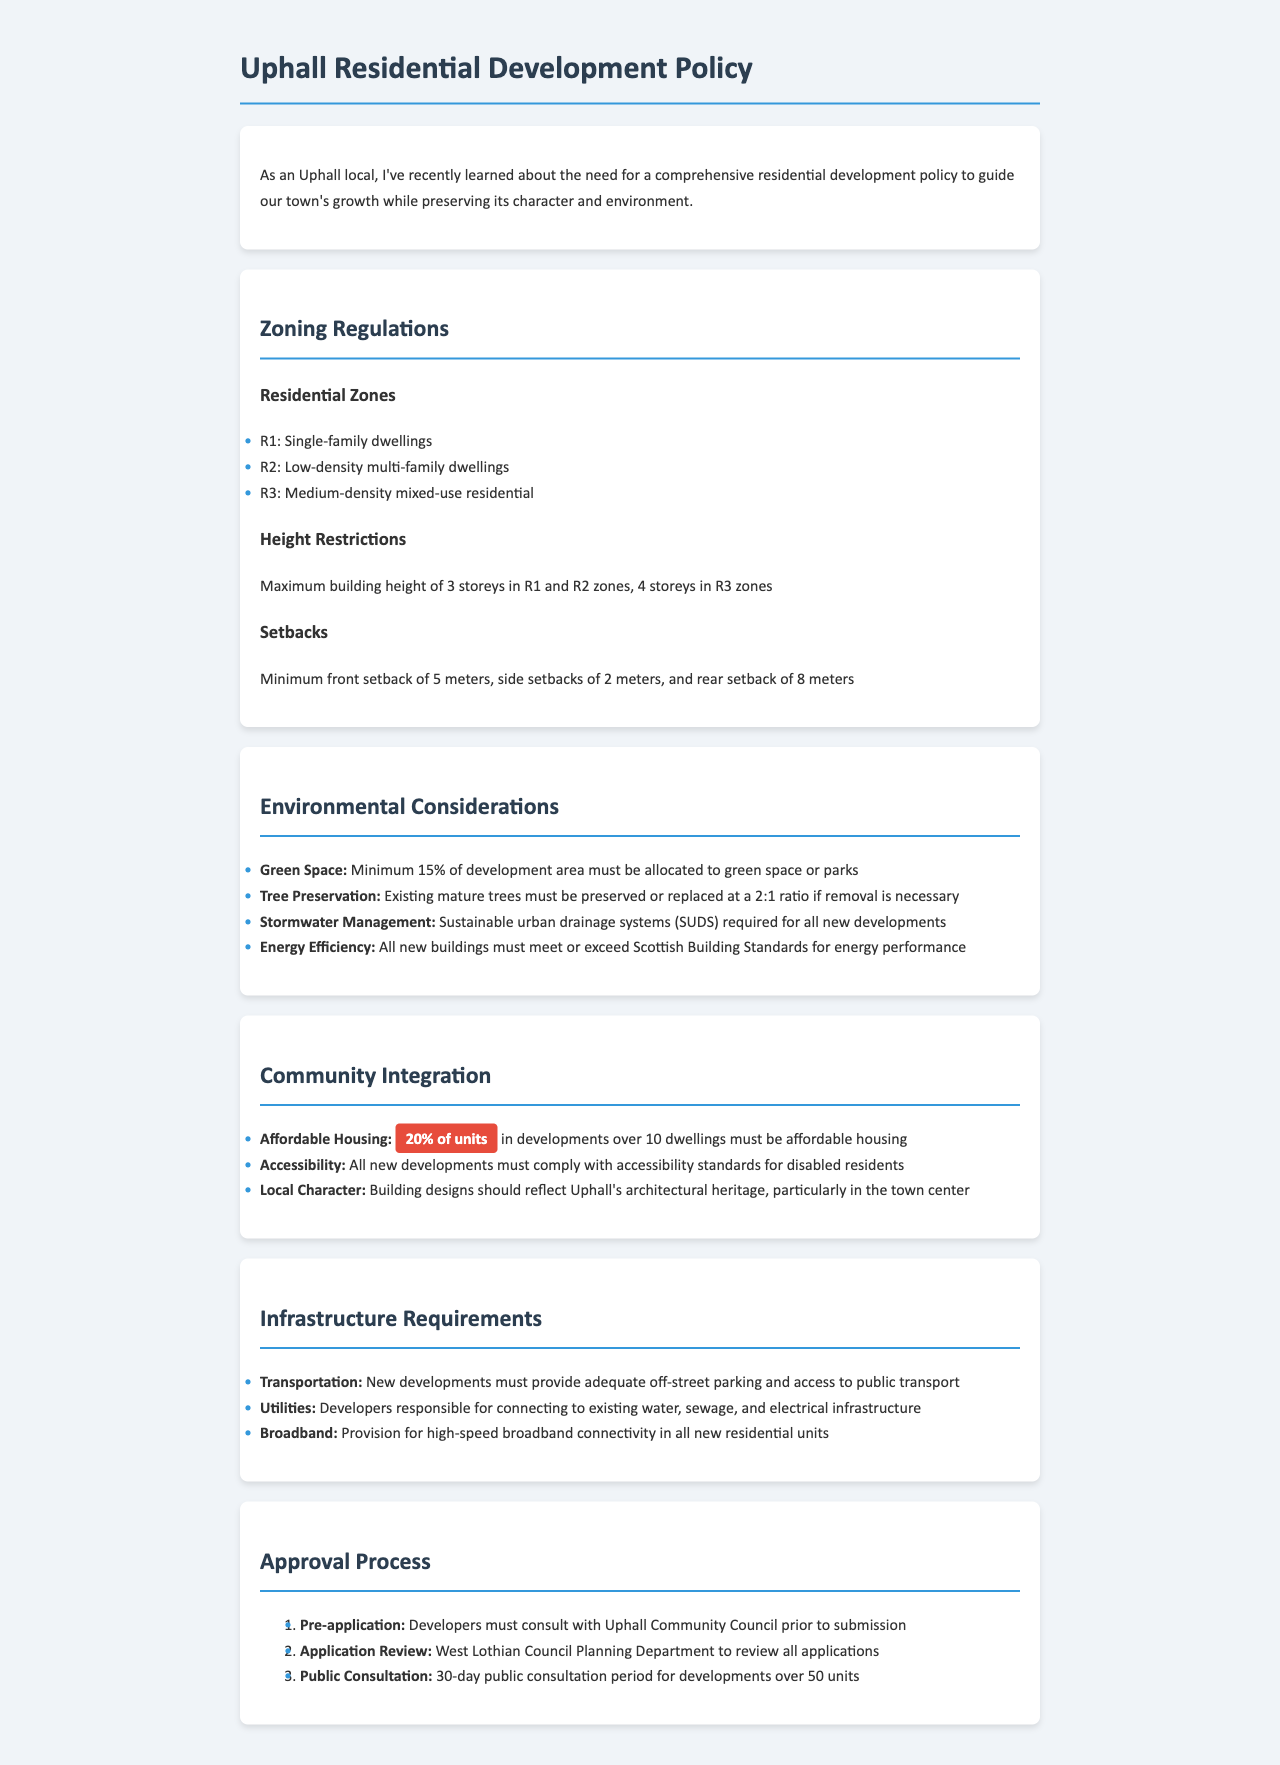What are the residential zones in Uphall? The document lists three residential zones: R1, R2, and R3.
Answer: R1, R2, R3 What is the maximum building height in R3 zones? The policy states that the maximum building height in R3 zones is 4 storeys.
Answer: 4 storeys What percentage of the development area must be allocated to green space? The document specifies that a minimum of 15% of the development area must be allocated to green space or parks.
Answer: 15% How many units must be affordable housing in developments over 10 dwellings? The document indicates that 20% of units in developments over 10 dwellings must be affordable housing.
Answer: 20% What is required for stormwater management in new developments? The policy requires that all new developments implement sustainable urban drainage systems (SUDS).
Answer: SUDS What is the minimum front setback requirement? The document states that the minimum front setback is 5 meters.
Answer: 5 meters What is the first step in the approval process for developers? Developers must consult with Uphall Community Council prior to submission as the first step.
Answer: Consult with Uphall Community Council What should building designs reflect? The document states that building designs should reflect Uphall's architectural heritage, particularly in the town center.
Answer: Uphall's architectural heritage 